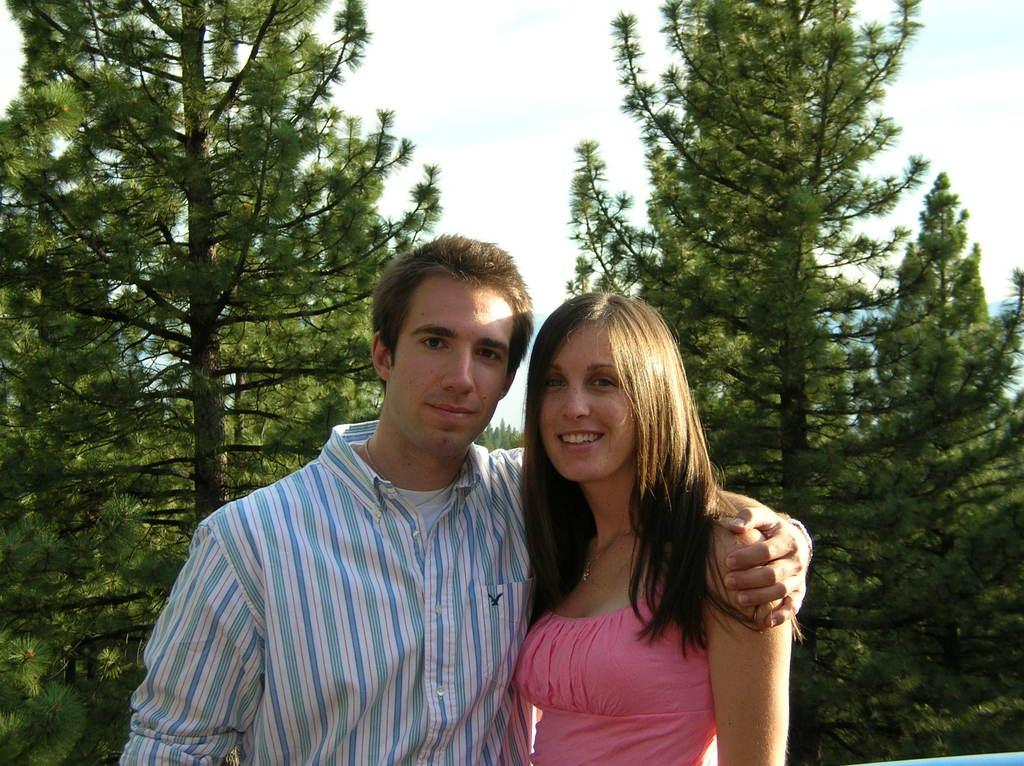Who is present in the picture? There is a couple in the picture. What are the couple doing in the picture? The couple is standing. What can be seen in the background of the picture? There are trees behind the couple. What size of farm can be seen in the background of the picture? There is no farm visible in the background of the picture; it features trees instead. What book is the couple reading together in the picture? There is no book present in the picture; the couple is simply standing. 